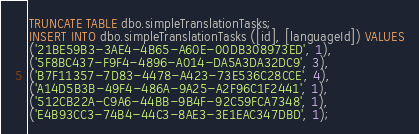<code> <loc_0><loc_0><loc_500><loc_500><_SQL_>TRUNCATE TABLE dbo.simpleTranslationTasks;
INSERT INTO dbo.simpleTranslationTasks ([id], [languageId]) VALUES
('21BE59B3-3AE4-4B65-A60E-00DB308973ED', 1),
('5F8BC437-F9F4-4896-A014-DA5A3DA32DC9', 3),
('B7F11357-7D83-4478-A423-73E536C28CCE', 4),
('A14D5B3B-49F4-486A-9A25-A2F96C1F2441', 1),
('512CB22A-C9A6-44BB-9B4F-92C59FCA7348', 1),
('E4B93CC3-74B4-44C3-8AE3-3E1EAC347DBD', 1);</code> 